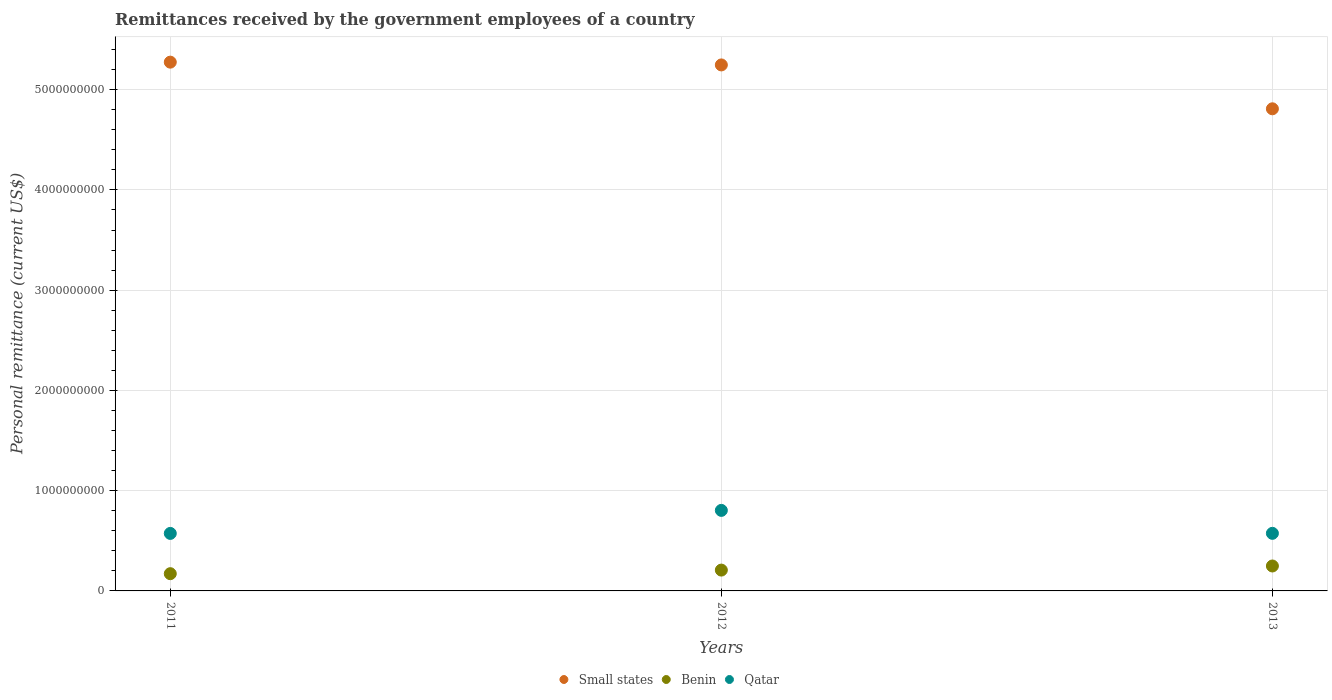How many different coloured dotlines are there?
Ensure brevity in your answer.  3. Is the number of dotlines equal to the number of legend labels?
Your answer should be compact. Yes. What is the remittances received by the government employees in Qatar in 2012?
Offer a terse response. 8.03e+08. Across all years, what is the maximum remittances received by the government employees in Benin?
Offer a terse response. 2.49e+08. Across all years, what is the minimum remittances received by the government employees in Qatar?
Offer a very short reply. 5.74e+08. In which year was the remittances received by the government employees in Qatar minimum?
Provide a short and direct response. 2011. What is the total remittances received by the government employees in Qatar in the graph?
Your answer should be very brief. 1.95e+09. What is the difference between the remittances received by the government employees in Small states in 2012 and that in 2013?
Make the answer very short. 4.38e+08. What is the difference between the remittances received by the government employees in Benin in 2011 and the remittances received by the government employees in Qatar in 2013?
Give a very brief answer. -4.02e+08. What is the average remittances received by the government employees in Qatar per year?
Offer a very short reply. 6.50e+08. In the year 2013, what is the difference between the remittances received by the government employees in Small states and remittances received by the government employees in Benin?
Keep it short and to the point. 4.56e+09. What is the ratio of the remittances received by the government employees in Small states in 2011 to that in 2013?
Your response must be concise. 1.1. Is the remittances received by the government employees in Small states in 2012 less than that in 2013?
Provide a short and direct response. No. What is the difference between the highest and the second highest remittances received by the government employees in Qatar?
Offer a terse response. 2.29e+08. What is the difference between the highest and the lowest remittances received by the government employees in Qatar?
Keep it short and to the point. 2.30e+08. Is the sum of the remittances received by the government employees in Benin in 2011 and 2013 greater than the maximum remittances received by the government employees in Qatar across all years?
Keep it short and to the point. No. Is the remittances received by the government employees in Qatar strictly greater than the remittances received by the government employees in Benin over the years?
Your answer should be compact. Yes. Is the remittances received by the government employees in Qatar strictly less than the remittances received by the government employees in Benin over the years?
Make the answer very short. No. Does the graph contain grids?
Provide a short and direct response. Yes. Where does the legend appear in the graph?
Ensure brevity in your answer.  Bottom center. How many legend labels are there?
Your response must be concise. 3. What is the title of the graph?
Your response must be concise. Remittances received by the government employees of a country. What is the label or title of the X-axis?
Keep it short and to the point. Years. What is the label or title of the Y-axis?
Make the answer very short. Personal remittance (current US$). What is the Personal remittance (current US$) in Small states in 2011?
Give a very brief answer. 5.27e+09. What is the Personal remittance (current US$) in Benin in 2011?
Provide a succinct answer. 1.72e+08. What is the Personal remittance (current US$) of Qatar in 2011?
Give a very brief answer. 5.74e+08. What is the Personal remittance (current US$) in Small states in 2012?
Keep it short and to the point. 5.25e+09. What is the Personal remittance (current US$) of Benin in 2012?
Keep it short and to the point. 2.08e+08. What is the Personal remittance (current US$) in Qatar in 2012?
Give a very brief answer. 8.03e+08. What is the Personal remittance (current US$) of Small states in 2013?
Your response must be concise. 4.81e+09. What is the Personal remittance (current US$) of Benin in 2013?
Provide a short and direct response. 2.49e+08. What is the Personal remittance (current US$) in Qatar in 2013?
Ensure brevity in your answer.  5.74e+08. Across all years, what is the maximum Personal remittance (current US$) of Small states?
Ensure brevity in your answer.  5.27e+09. Across all years, what is the maximum Personal remittance (current US$) in Benin?
Provide a succinct answer. 2.49e+08. Across all years, what is the maximum Personal remittance (current US$) in Qatar?
Your response must be concise. 8.03e+08. Across all years, what is the minimum Personal remittance (current US$) in Small states?
Your response must be concise. 4.81e+09. Across all years, what is the minimum Personal remittance (current US$) of Benin?
Offer a terse response. 1.72e+08. Across all years, what is the minimum Personal remittance (current US$) in Qatar?
Keep it short and to the point. 5.74e+08. What is the total Personal remittance (current US$) of Small states in the graph?
Ensure brevity in your answer.  1.53e+1. What is the total Personal remittance (current US$) of Benin in the graph?
Your answer should be compact. 6.28e+08. What is the total Personal remittance (current US$) in Qatar in the graph?
Provide a succinct answer. 1.95e+09. What is the difference between the Personal remittance (current US$) of Small states in 2011 and that in 2012?
Provide a succinct answer. 2.77e+07. What is the difference between the Personal remittance (current US$) in Benin in 2011 and that in 2012?
Provide a short and direct response. -3.58e+07. What is the difference between the Personal remittance (current US$) in Qatar in 2011 and that in 2012?
Provide a succinct answer. -2.30e+08. What is the difference between the Personal remittance (current US$) of Small states in 2011 and that in 2013?
Your answer should be very brief. 4.65e+08. What is the difference between the Personal remittance (current US$) in Benin in 2011 and that in 2013?
Offer a very short reply. -7.68e+07. What is the difference between the Personal remittance (current US$) of Qatar in 2011 and that in 2013?
Keep it short and to the point. -7.69e+05. What is the difference between the Personal remittance (current US$) of Small states in 2012 and that in 2013?
Ensure brevity in your answer.  4.38e+08. What is the difference between the Personal remittance (current US$) of Benin in 2012 and that in 2013?
Provide a succinct answer. -4.10e+07. What is the difference between the Personal remittance (current US$) of Qatar in 2012 and that in 2013?
Your answer should be very brief. 2.29e+08. What is the difference between the Personal remittance (current US$) of Small states in 2011 and the Personal remittance (current US$) of Benin in 2012?
Give a very brief answer. 5.07e+09. What is the difference between the Personal remittance (current US$) in Small states in 2011 and the Personal remittance (current US$) in Qatar in 2012?
Give a very brief answer. 4.47e+09. What is the difference between the Personal remittance (current US$) in Benin in 2011 and the Personal remittance (current US$) in Qatar in 2012?
Provide a short and direct response. -6.31e+08. What is the difference between the Personal remittance (current US$) in Small states in 2011 and the Personal remittance (current US$) in Benin in 2013?
Provide a succinct answer. 5.03e+09. What is the difference between the Personal remittance (current US$) of Small states in 2011 and the Personal remittance (current US$) of Qatar in 2013?
Provide a short and direct response. 4.70e+09. What is the difference between the Personal remittance (current US$) in Benin in 2011 and the Personal remittance (current US$) in Qatar in 2013?
Provide a short and direct response. -4.02e+08. What is the difference between the Personal remittance (current US$) of Small states in 2012 and the Personal remittance (current US$) of Benin in 2013?
Offer a terse response. 5.00e+09. What is the difference between the Personal remittance (current US$) of Small states in 2012 and the Personal remittance (current US$) of Qatar in 2013?
Offer a terse response. 4.67e+09. What is the difference between the Personal remittance (current US$) in Benin in 2012 and the Personal remittance (current US$) in Qatar in 2013?
Offer a terse response. -3.67e+08. What is the average Personal remittance (current US$) in Small states per year?
Offer a very short reply. 5.11e+09. What is the average Personal remittance (current US$) of Benin per year?
Offer a terse response. 2.09e+08. What is the average Personal remittance (current US$) in Qatar per year?
Offer a very short reply. 6.50e+08. In the year 2011, what is the difference between the Personal remittance (current US$) of Small states and Personal remittance (current US$) of Benin?
Provide a short and direct response. 5.10e+09. In the year 2011, what is the difference between the Personal remittance (current US$) of Small states and Personal remittance (current US$) of Qatar?
Your answer should be very brief. 4.70e+09. In the year 2011, what is the difference between the Personal remittance (current US$) in Benin and Personal remittance (current US$) in Qatar?
Provide a succinct answer. -4.02e+08. In the year 2012, what is the difference between the Personal remittance (current US$) in Small states and Personal remittance (current US$) in Benin?
Provide a succinct answer. 5.04e+09. In the year 2012, what is the difference between the Personal remittance (current US$) in Small states and Personal remittance (current US$) in Qatar?
Your response must be concise. 4.44e+09. In the year 2012, what is the difference between the Personal remittance (current US$) of Benin and Personal remittance (current US$) of Qatar?
Your answer should be compact. -5.96e+08. In the year 2013, what is the difference between the Personal remittance (current US$) of Small states and Personal remittance (current US$) of Benin?
Your answer should be very brief. 4.56e+09. In the year 2013, what is the difference between the Personal remittance (current US$) of Small states and Personal remittance (current US$) of Qatar?
Give a very brief answer. 4.23e+09. In the year 2013, what is the difference between the Personal remittance (current US$) of Benin and Personal remittance (current US$) of Qatar?
Ensure brevity in your answer.  -3.26e+08. What is the ratio of the Personal remittance (current US$) of Benin in 2011 to that in 2012?
Your answer should be compact. 0.83. What is the ratio of the Personal remittance (current US$) in Qatar in 2011 to that in 2012?
Offer a terse response. 0.71. What is the ratio of the Personal remittance (current US$) of Small states in 2011 to that in 2013?
Provide a succinct answer. 1.1. What is the ratio of the Personal remittance (current US$) in Benin in 2011 to that in 2013?
Your answer should be compact. 0.69. What is the ratio of the Personal remittance (current US$) of Qatar in 2011 to that in 2013?
Ensure brevity in your answer.  1. What is the ratio of the Personal remittance (current US$) of Small states in 2012 to that in 2013?
Give a very brief answer. 1.09. What is the ratio of the Personal remittance (current US$) in Benin in 2012 to that in 2013?
Ensure brevity in your answer.  0.84. What is the ratio of the Personal remittance (current US$) of Qatar in 2012 to that in 2013?
Offer a very short reply. 1.4. What is the difference between the highest and the second highest Personal remittance (current US$) in Small states?
Make the answer very short. 2.77e+07. What is the difference between the highest and the second highest Personal remittance (current US$) of Benin?
Your response must be concise. 4.10e+07. What is the difference between the highest and the second highest Personal remittance (current US$) of Qatar?
Offer a very short reply. 2.29e+08. What is the difference between the highest and the lowest Personal remittance (current US$) of Small states?
Keep it short and to the point. 4.65e+08. What is the difference between the highest and the lowest Personal remittance (current US$) of Benin?
Provide a short and direct response. 7.68e+07. What is the difference between the highest and the lowest Personal remittance (current US$) in Qatar?
Offer a terse response. 2.30e+08. 